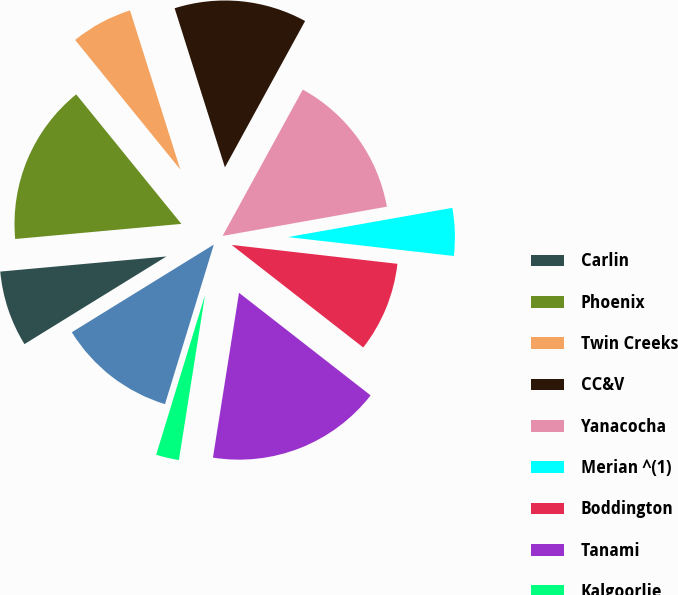<chart> <loc_0><loc_0><loc_500><loc_500><pie_chart><fcel>Carlin<fcel>Phoenix<fcel>Twin Creeks<fcel>CC&V<fcel>Yanacocha<fcel>Merian ^(1)<fcel>Boddington<fcel>Tanami<fcel>Kalgoorlie<fcel>Ahafo<nl><fcel>7.36%<fcel>15.59%<fcel>5.98%<fcel>12.85%<fcel>14.22%<fcel>4.61%<fcel>8.73%<fcel>16.96%<fcel>2.23%<fcel>11.47%<nl></chart> 